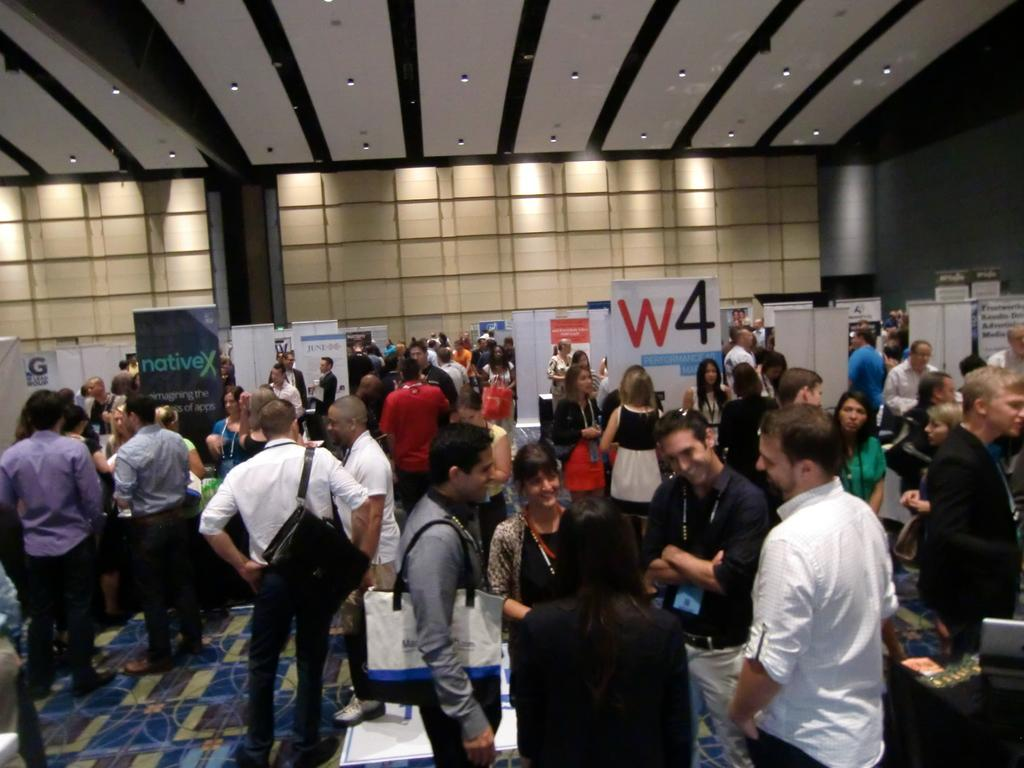Who or what can be seen in the image? There are people in the image. What is the surface beneath the people in the image? The ground is visible in the image. What type of signage is present in the image? There are boards with text written in the image. What type of structure is visible in the image? There is a wall in the image. What is on top of the structure in the image? There is a roof with lights in the image. What is the texture of the bricks on the wall in the image? There are no bricks visible in the image; the wall appears to be made of a different material. 